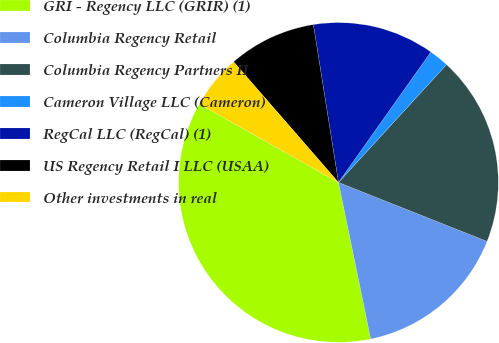Convert chart to OTSL. <chart><loc_0><loc_0><loc_500><loc_500><pie_chart><fcel>GRI - Regency LLC (GRIR) (1)<fcel>Columbia Regency Retail<fcel>Columbia Regency Partners II<fcel>Cameron Village LLC (Cameron)<fcel>RegCal LLC (RegCal) (1)<fcel>US Regency Retail I LLC (USAA)<fcel>Other investments in real<nl><fcel>36.4%<fcel>15.76%<fcel>19.2%<fcel>2.0%<fcel>12.32%<fcel>8.88%<fcel>5.44%<nl></chart> 